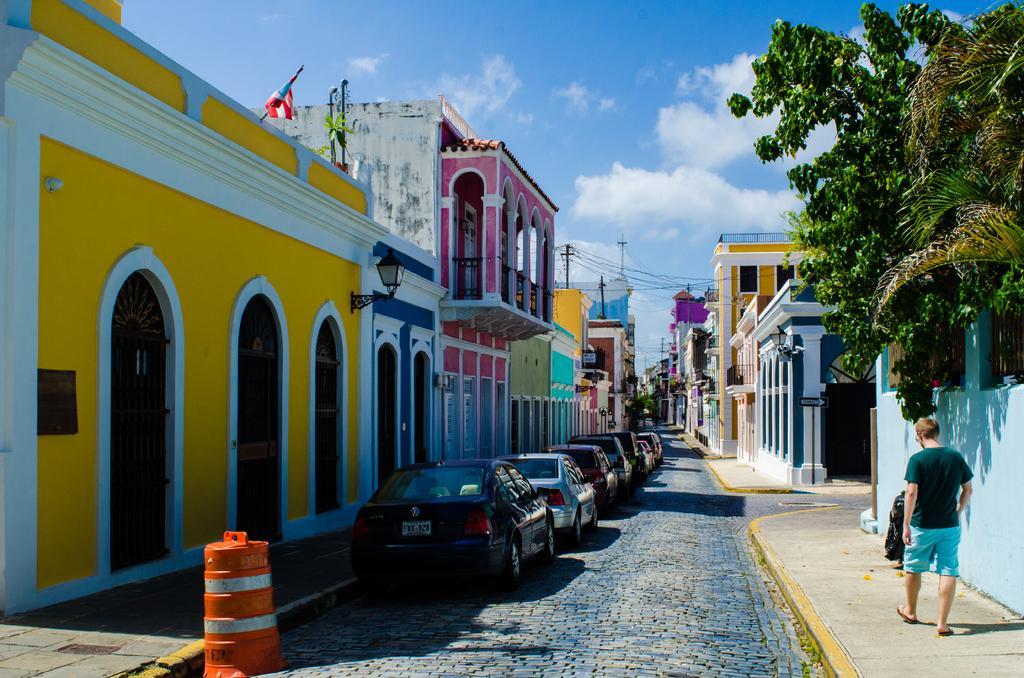Please provide a concise description of this image. In the picture we can see a path, on the both the sides of the path we can see houses with different colors and near the houses we can see cars are parked and opposite side, we can see a wall behind it, we can see a part of the tree and in the background we can see some poles with wires and in the background we can see the sky with clouds. 